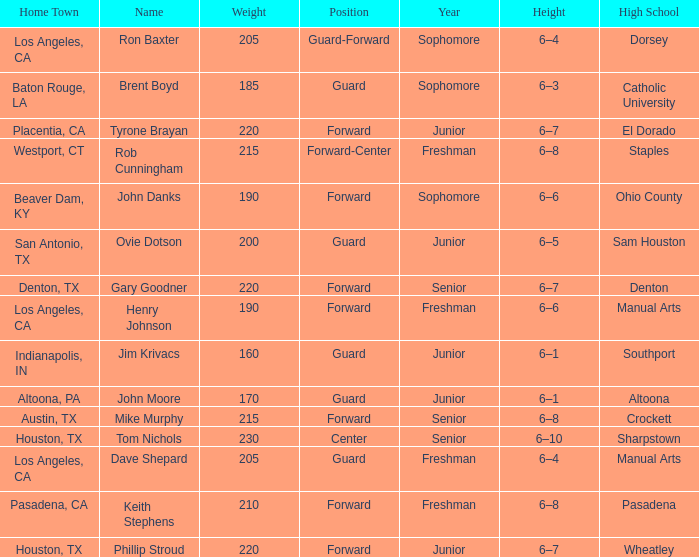Would you be able to parse every entry in this table? {'header': ['Home Town', 'Name', 'Weight', 'Position', 'Year', 'Height', 'High School'], 'rows': [['Los Angeles, CA', 'Ron Baxter', '205', 'Guard-Forward', 'Sophomore', '6–4', 'Dorsey'], ['Baton Rouge, LA', 'Brent Boyd', '185', 'Guard', 'Sophomore', '6–3', 'Catholic University'], ['Placentia, CA', 'Tyrone Brayan', '220', 'Forward', 'Junior', '6–7', 'El Dorado'], ['Westport, CT', 'Rob Cunningham', '215', 'Forward-Center', 'Freshman', '6–8', 'Staples'], ['Beaver Dam, KY', 'John Danks', '190', 'Forward', 'Sophomore', '6–6', 'Ohio County'], ['San Antonio, TX', 'Ovie Dotson', '200', 'Guard', 'Junior', '6–5', 'Sam Houston'], ['Denton, TX', 'Gary Goodner', '220', 'Forward', 'Senior', '6–7', 'Denton'], ['Los Angeles, CA', 'Henry Johnson', '190', 'Forward', 'Freshman', '6–6', 'Manual Arts'], ['Indianapolis, IN', 'Jim Krivacs', '160', 'Guard', 'Junior', '6–1', 'Southport'], ['Altoona, PA', 'John Moore', '170', 'Guard', 'Junior', '6–1', 'Altoona'], ['Austin, TX', 'Mike Murphy', '215', 'Forward', 'Senior', '6–8', 'Crockett'], ['Houston, TX', 'Tom Nichols', '230', 'Center', 'Senior', '6–10', 'Sharpstown'], ['Los Angeles, CA', 'Dave Shepard', '205', 'Guard', 'Freshman', '6–4', 'Manual Arts'], ['Pasadena, CA', 'Keith Stephens', '210', 'Forward', 'Freshman', '6–8', 'Pasadena'], ['Houston, TX', 'Phillip Stroud', '220', 'Forward', 'Junior', '6–7', 'Wheatley']]} What is the Name with a Year of junior, and a High School with wheatley? Phillip Stroud. 